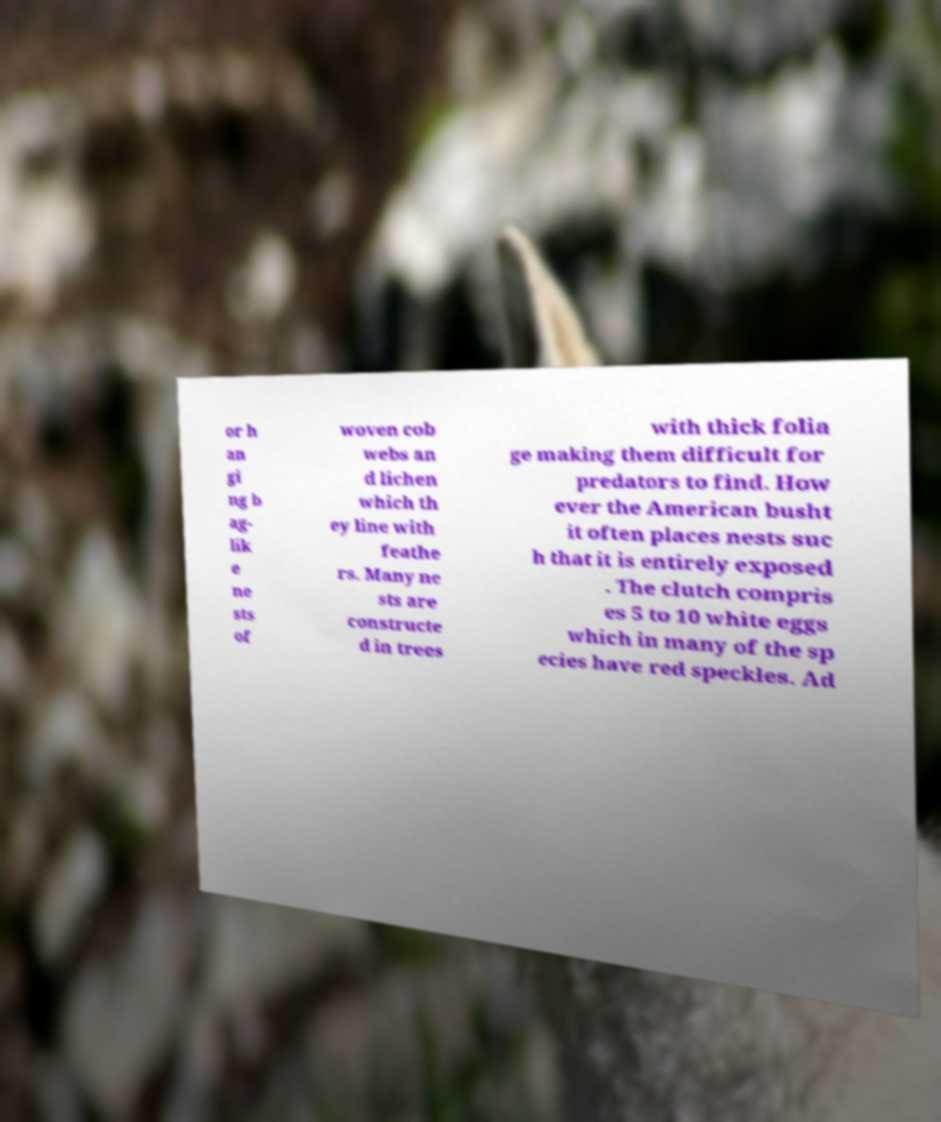Could you assist in decoding the text presented in this image and type it out clearly? or h an gi ng b ag- lik e ne sts of woven cob webs an d lichen which th ey line with feathe rs. Many ne sts are constructe d in trees with thick folia ge making them difficult for predators to find. How ever the American busht it often places nests suc h that it is entirely exposed . The clutch compris es 5 to 10 white eggs which in many of the sp ecies have red speckles. Ad 